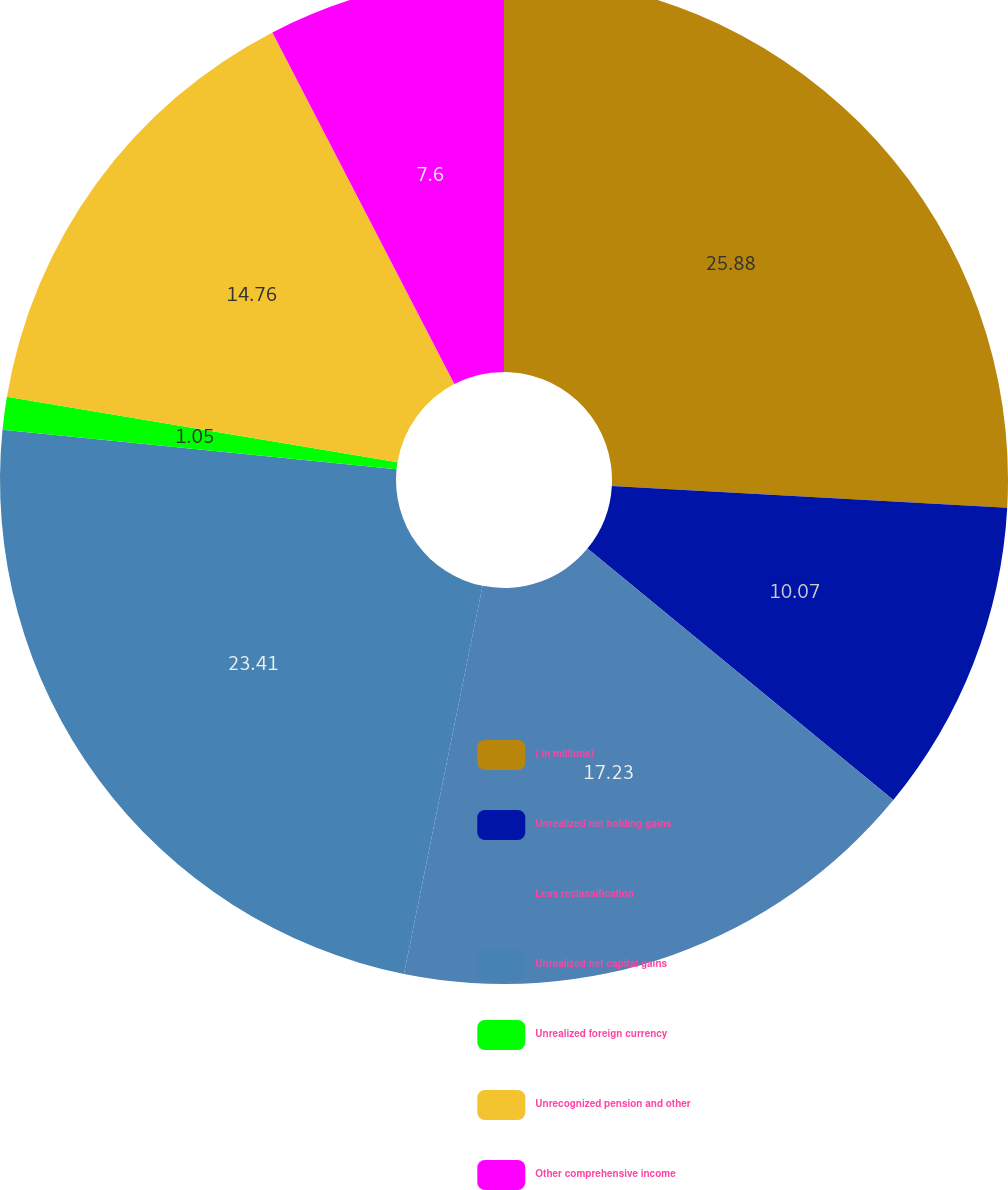<chart> <loc_0><loc_0><loc_500><loc_500><pie_chart><fcel>( in millions)<fcel>Unrealized net holding gains<fcel>Less reclassification<fcel>Unrealized net capital gains<fcel>Unrealized foreign currency<fcel>Unrecognized pension and other<fcel>Other comprehensive income<nl><fcel>25.88%<fcel>10.07%<fcel>17.23%<fcel>23.41%<fcel>1.05%<fcel>14.76%<fcel>7.6%<nl></chart> 